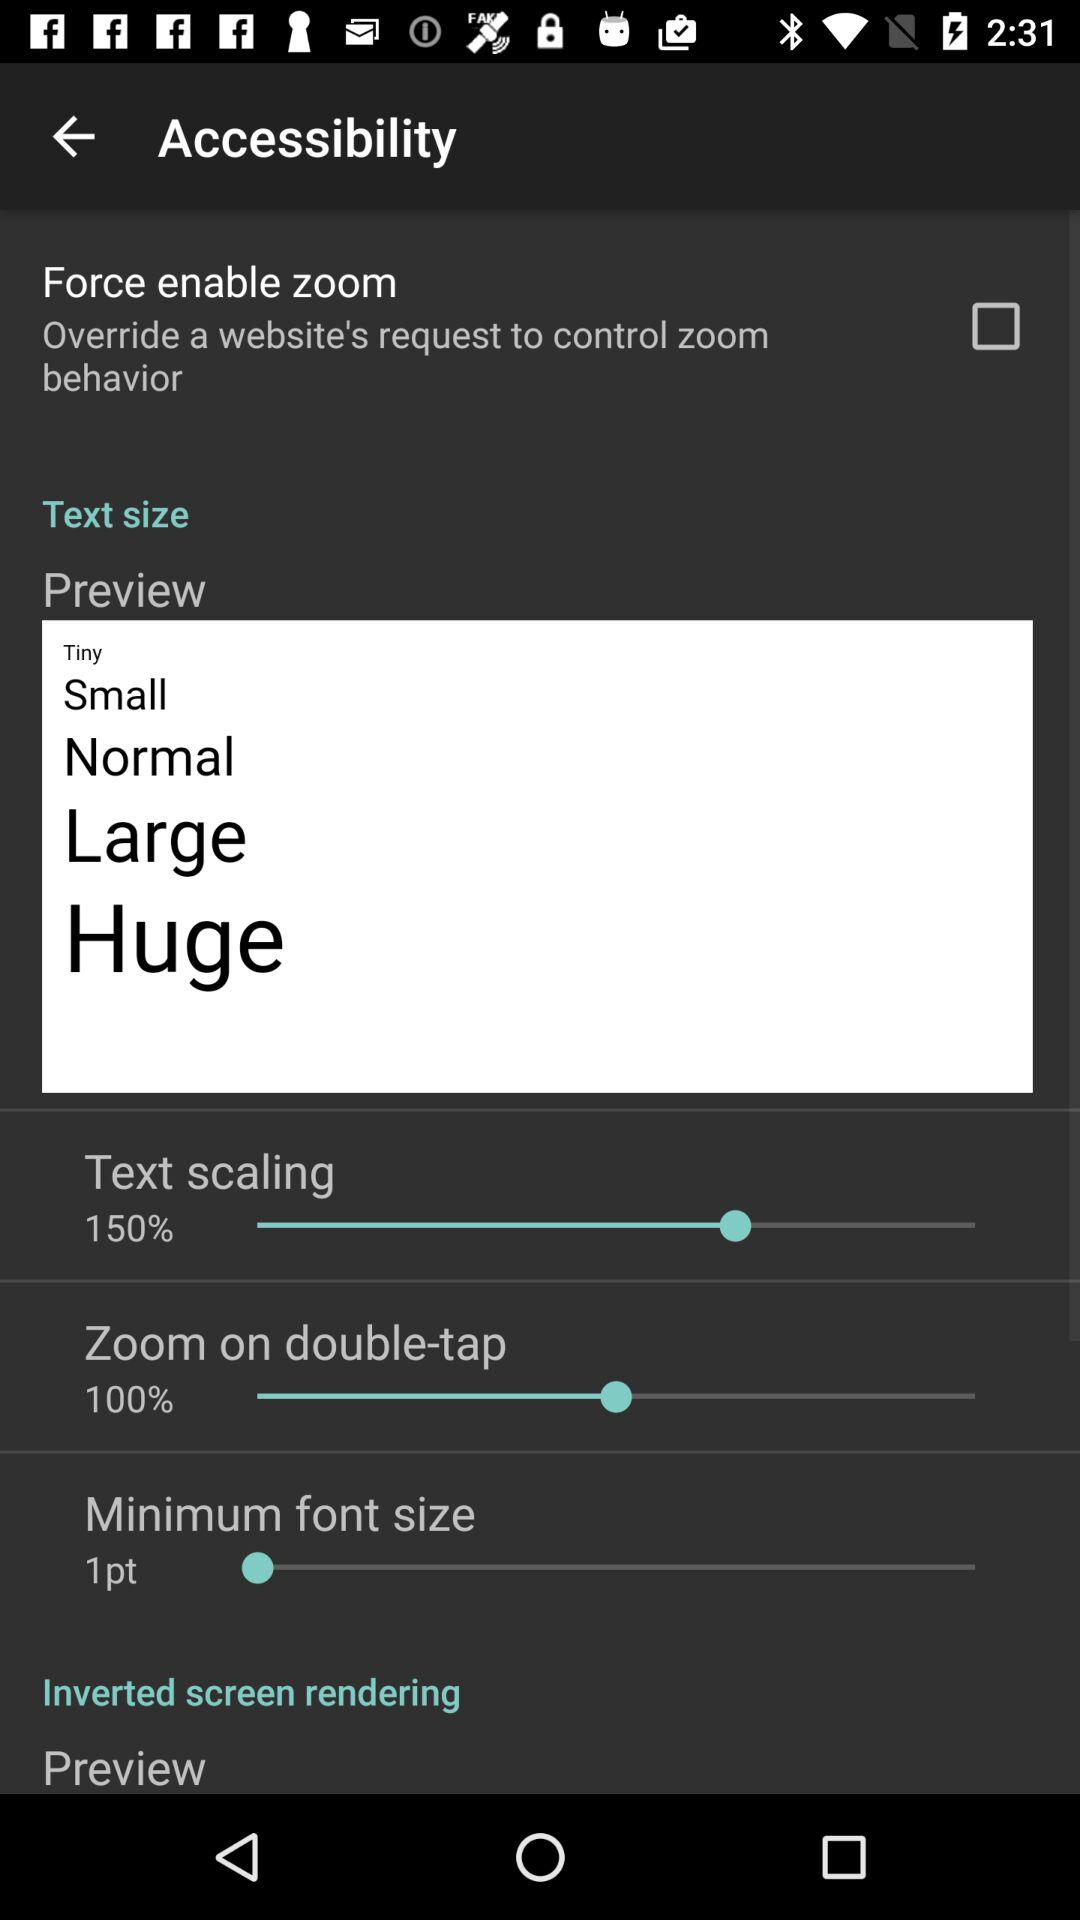What is the percentage of zoom on double-tap? The percentage of zoom on double-tap is 100%. 